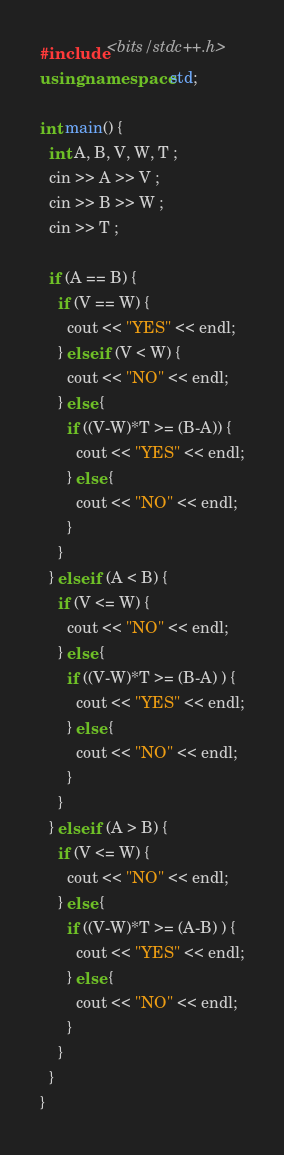<code> <loc_0><loc_0><loc_500><loc_500><_C++_>#include <bits/stdc++.h>
using namespace std;

int main() {
  int A, B, V, W, T ;
  cin >> A >> V ;
  cin >> B >> W ;
  cin >> T ;

  if (A == B) {
    if (V == W) {
      cout << "YES" << endl;
    } else if (V < W) {
      cout << "NO" << endl;
    } else {
      if ((V-W)*T >= (B-A)) {
        cout << "YES" << endl;
      } else {
        cout << "NO" << endl;
      }
    }
  } else if (A < B) {
    if (V <= W) {
      cout << "NO" << endl;
    } else {
      if ((V-W)*T >= (B-A) ) {
        cout << "YES" << endl;
      } else {
        cout << "NO" << endl;
      }
    }
  } else if (A > B) {
    if (V <= W) {
      cout << "NO" << endl;
    } else {
      if ((V-W)*T >= (A-B) ) {
        cout << "YES" << endl;
      } else {
        cout << "NO" << endl;
      }
    }
  }
}
</code> 